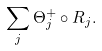<formula> <loc_0><loc_0><loc_500><loc_500>\sum _ { j } \Theta ^ { + } _ { j } \circ R _ { j } .</formula> 